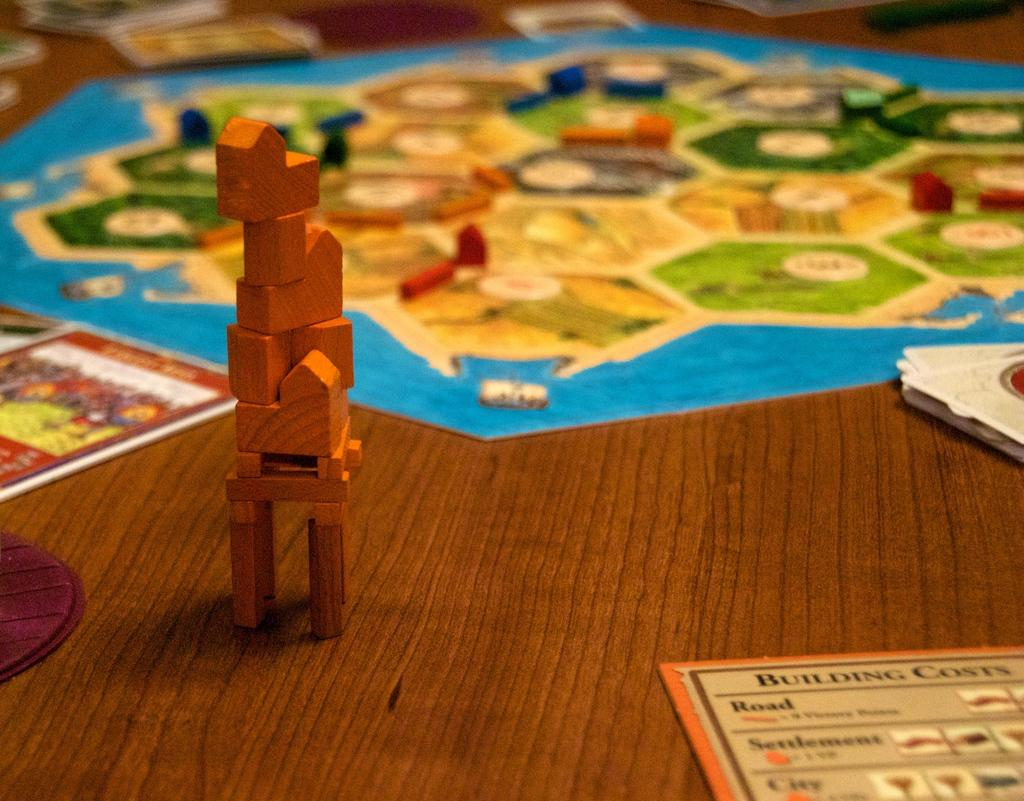<image>
Give a short and clear explanation of the subsequent image. a paper on the table that says 'building costs' on it 